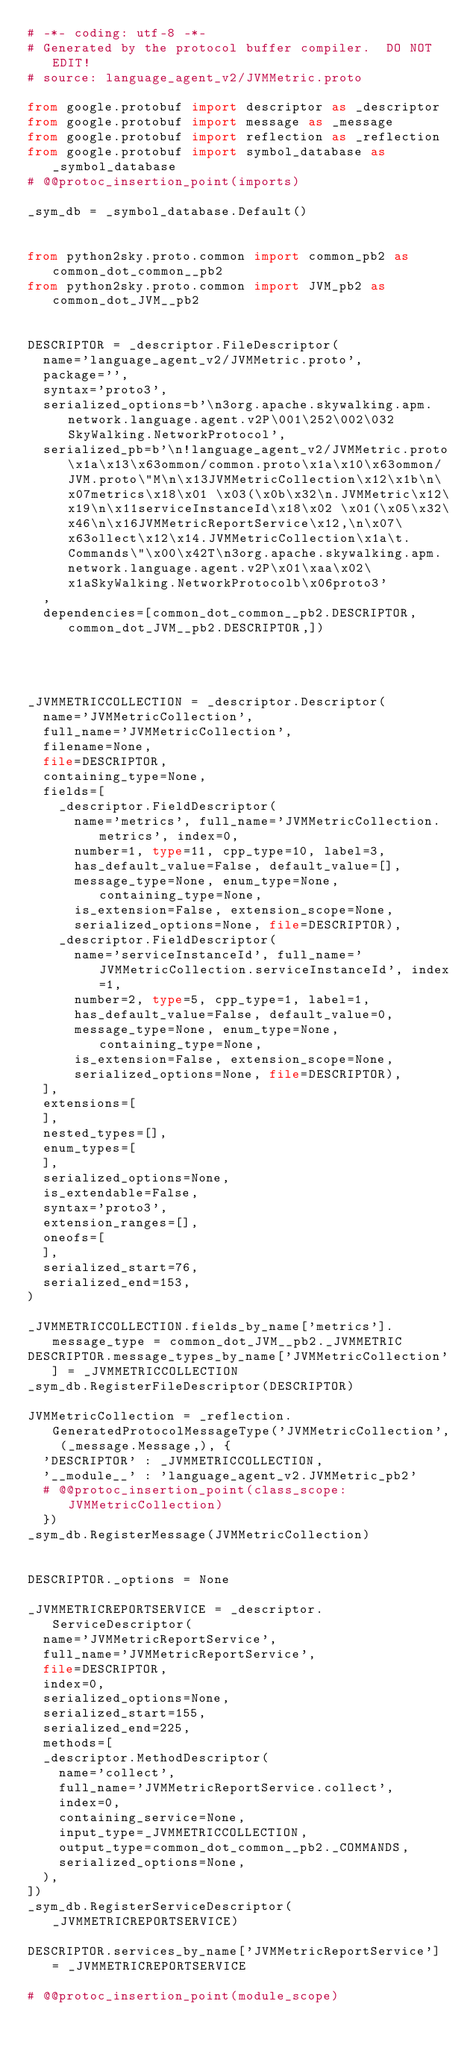Convert code to text. <code><loc_0><loc_0><loc_500><loc_500><_Python_># -*- coding: utf-8 -*-
# Generated by the protocol buffer compiler.  DO NOT EDIT!
# source: language_agent_v2/JVMMetric.proto

from google.protobuf import descriptor as _descriptor
from google.protobuf import message as _message
from google.protobuf import reflection as _reflection
from google.protobuf import symbol_database as _symbol_database
# @@protoc_insertion_point(imports)

_sym_db = _symbol_database.Default()


from python2sky.proto.common import common_pb2 as common_dot_common__pb2
from python2sky.proto.common import JVM_pb2 as common_dot_JVM__pb2


DESCRIPTOR = _descriptor.FileDescriptor(
  name='language_agent_v2/JVMMetric.proto',
  package='',
  syntax='proto3',
  serialized_options=b'\n3org.apache.skywalking.apm.network.language.agent.v2P\001\252\002\032SkyWalking.NetworkProtocol',
  serialized_pb=b'\n!language_agent_v2/JVMMetric.proto\x1a\x13\x63ommon/common.proto\x1a\x10\x63ommon/JVM.proto\"M\n\x13JVMMetricCollection\x12\x1b\n\x07metrics\x18\x01 \x03(\x0b\x32\n.JVMMetric\x12\x19\n\x11serviceInstanceId\x18\x02 \x01(\x05\x32\x46\n\x16JVMMetricReportService\x12,\n\x07\x63ollect\x12\x14.JVMMetricCollection\x1a\t.Commands\"\x00\x42T\n3org.apache.skywalking.apm.network.language.agent.v2P\x01\xaa\x02\x1aSkyWalking.NetworkProtocolb\x06proto3'
  ,
  dependencies=[common_dot_common__pb2.DESCRIPTOR,common_dot_JVM__pb2.DESCRIPTOR,])




_JVMMETRICCOLLECTION = _descriptor.Descriptor(
  name='JVMMetricCollection',
  full_name='JVMMetricCollection',
  filename=None,
  file=DESCRIPTOR,
  containing_type=None,
  fields=[
    _descriptor.FieldDescriptor(
      name='metrics', full_name='JVMMetricCollection.metrics', index=0,
      number=1, type=11, cpp_type=10, label=3,
      has_default_value=False, default_value=[],
      message_type=None, enum_type=None, containing_type=None,
      is_extension=False, extension_scope=None,
      serialized_options=None, file=DESCRIPTOR),
    _descriptor.FieldDescriptor(
      name='serviceInstanceId', full_name='JVMMetricCollection.serviceInstanceId', index=1,
      number=2, type=5, cpp_type=1, label=1,
      has_default_value=False, default_value=0,
      message_type=None, enum_type=None, containing_type=None,
      is_extension=False, extension_scope=None,
      serialized_options=None, file=DESCRIPTOR),
  ],
  extensions=[
  ],
  nested_types=[],
  enum_types=[
  ],
  serialized_options=None,
  is_extendable=False,
  syntax='proto3',
  extension_ranges=[],
  oneofs=[
  ],
  serialized_start=76,
  serialized_end=153,
)

_JVMMETRICCOLLECTION.fields_by_name['metrics'].message_type = common_dot_JVM__pb2._JVMMETRIC
DESCRIPTOR.message_types_by_name['JVMMetricCollection'] = _JVMMETRICCOLLECTION
_sym_db.RegisterFileDescriptor(DESCRIPTOR)

JVMMetricCollection = _reflection.GeneratedProtocolMessageType('JVMMetricCollection', (_message.Message,), {
  'DESCRIPTOR' : _JVMMETRICCOLLECTION,
  '__module__' : 'language_agent_v2.JVMMetric_pb2'
  # @@protoc_insertion_point(class_scope:JVMMetricCollection)
  })
_sym_db.RegisterMessage(JVMMetricCollection)


DESCRIPTOR._options = None

_JVMMETRICREPORTSERVICE = _descriptor.ServiceDescriptor(
  name='JVMMetricReportService',
  full_name='JVMMetricReportService',
  file=DESCRIPTOR,
  index=0,
  serialized_options=None,
  serialized_start=155,
  serialized_end=225,
  methods=[
  _descriptor.MethodDescriptor(
    name='collect',
    full_name='JVMMetricReportService.collect',
    index=0,
    containing_service=None,
    input_type=_JVMMETRICCOLLECTION,
    output_type=common_dot_common__pb2._COMMANDS,
    serialized_options=None,
  ),
])
_sym_db.RegisterServiceDescriptor(_JVMMETRICREPORTSERVICE)

DESCRIPTOR.services_by_name['JVMMetricReportService'] = _JVMMETRICREPORTSERVICE

# @@protoc_insertion_point(module_scope)
</code> 